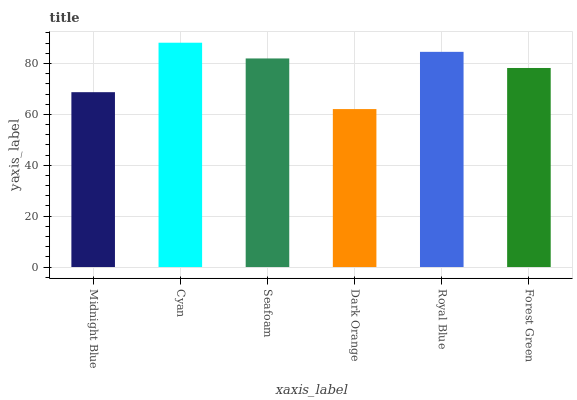Is Dark Orange the minimum?
Answer yes or no. Yes. Is Cyan the maximum?
Answer yes or no. Yes. Is Seafoam the minimum?
Answer yes or no. No. Is Seafoam the maximum?
Answer yes or no. No. Is Cyan greater than Seafoam?
Answer yes or no. Yes. Is Seafoam less than Cyan?
Answer yes or no. Yes. Is Seafoam greater than Cyan?
Answer yes or no. No. Is Cyan less than Seafoam?
Answer yes or no. No. Is Seafoam the high median?
Answer yes or no. Yes. Is Forest Green the low median?
Answer yes or no. Yes. Is Midnight Blue the high median?
Answer yes or no. No. Is Midnight Blue the low median?
Answer yes or no. No. 